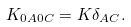<formula> <loc_0><loc_0><loc_500><loc_500>K _ { 0 A 0 C } = K { \delta } _ { A C } .</formula> 